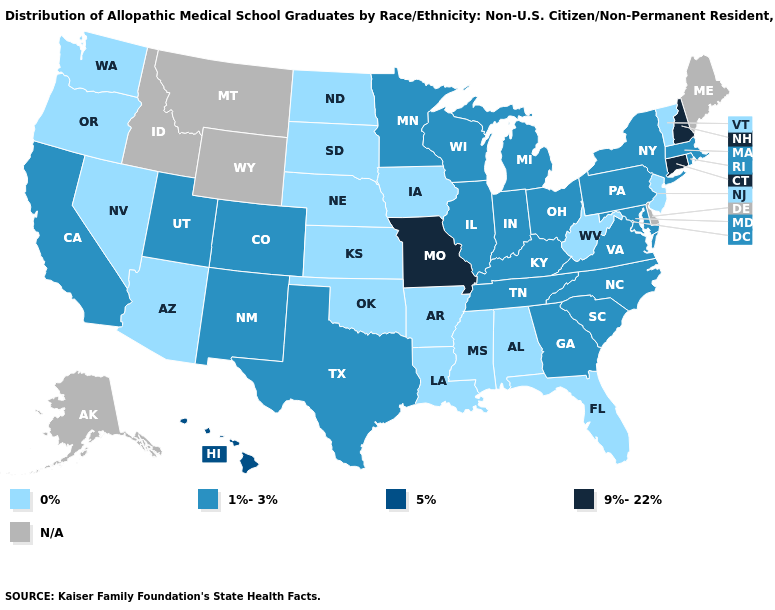What is the value of Rhode Island?
Concise answer only. 1%-3%. Does the map have missing data?
Concise answer only. Yes. What is the highest value in the USA?
Write a very short answer. 9%-22%. Name the states that have a value in the range N/A?
Write a very short answer. Alaska, Delaware, Idaho, Maine, Montana, Wyoming. Does West Virginia have the lowest value in the USA?
Be succinct. Yes. Is the legend a continuous bar?
Keep it brief. No. Name the states that have a value in the range 5%?
Answer briefly. Hawaii. Among the states that border Wyoming , which have the lowest value?
Write a very short answer. Nebraska, South Dakota. Does Missouri have the highest value in the USA?
Be succinct. Yes. What is the lowest value in the USA?
Write a very short answer. 0%. Among the states that border South Carolina , which have the highest value?
Be succinct. Georgia, North Carolina. Among the states that border Georgia , does Florida have the lowest value?
Answer briefly. Yes. What is the highest value in states that border Illinois?
Give a very brief answer. 9%-22%. Name the states that have a value in the range 5%?
Quick response, please. Hawaii. 